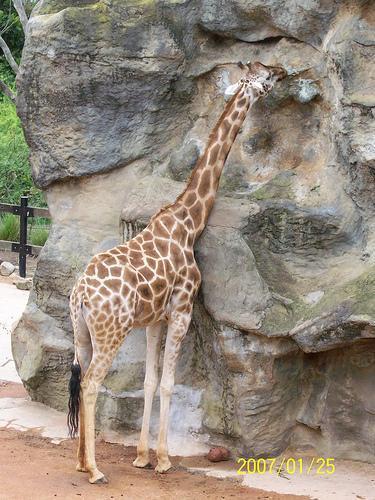How many giraffes?
Give a very brief answer. 1. 